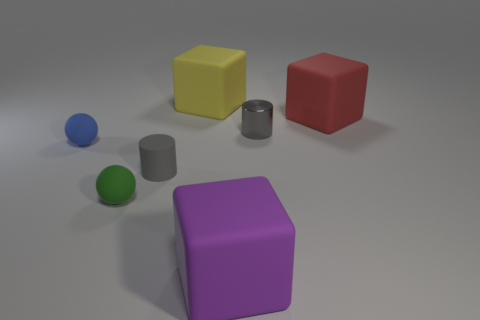What is the shape of the tiny object that is the same color as the small matte cylinder?
Your answer should be compact. Cylinder. There is a matte cylinder that is the same color as the small metal cylinder; what is its size?
Make the answer very short. Small. Is there a gray thing of the same shape as the purple object?
Keep it short and to the point. No. Is the number of small gray rubber cylinders on the left side of the blue rubber object the same as the number of purple things?
Offer a terse response. No. There is a gray cylinder on the left side of the tiny gray thing that is on the right side of the yellow rubber object; what is its material?
Your answer should be very brief. Rubber. What shape is the tiny green object?
Offer a terse response. Sphere. Are there the same number of large purple things on the left side of the large yellow thing and rubber objects that are in front of the small gray matte cylinder?
Make the answer very short. No. There is a tiny shiny thing in front of the large red thing; does it have the same color as the tiny cylinder that is to the left of the small gray shiny cylinder?
Your answer should be compact. Yes. Are there more red matte things that are right of the small green object than large cyan metallic blocks?
Give a very brief answer. Yes. There is a tiny gray thing that is the same material as the purple cube; what shape is it?
Keep it short and to the point. Cylinder. 